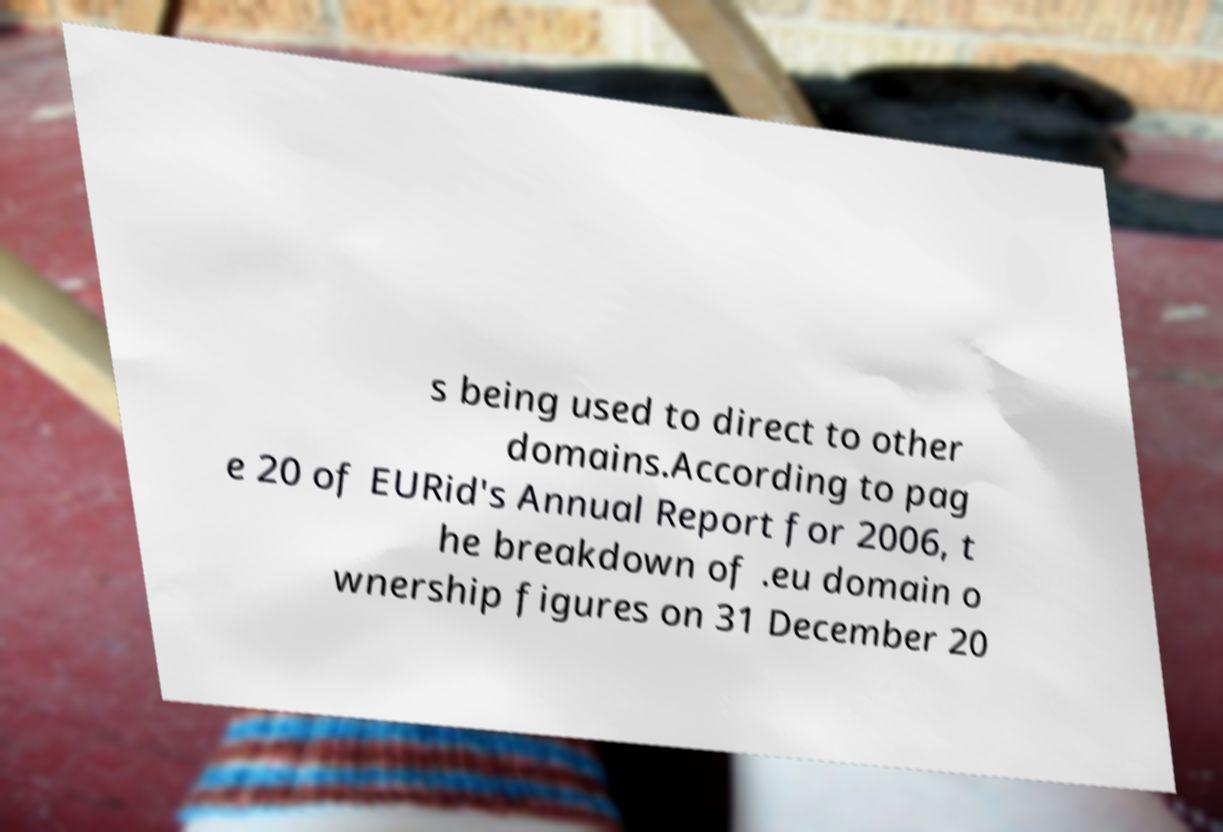There's text embedded in this image that I need extracted. Can you transcribe it verbatim? s being used to direct to other domains.According to pag e 20 of EURid's Annual Report for 2006, t he breakdown of .eu domain o wnership figures on 31 December 20 